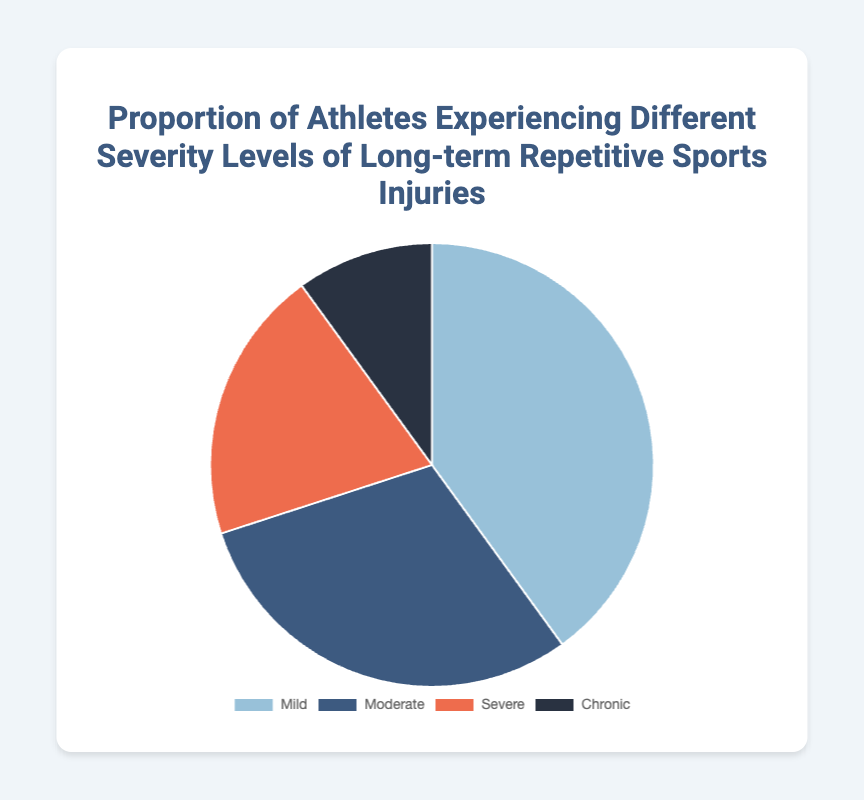What proportion of athletes experienced mild injuries? The slice labeled "Mild" corresponds to 40% of the pie chart's overall composition.
Answer: 40% How does the proportion of athletes with chronic injuries compare to those with severe injuries? The slice labeled "Chronic" represents 10%, while the slice labeled "Severe" represents 20%. Comparing these proportions, athletes with severe injuries account for twice the proportion of those with chronic injuries.
Answer: Severe injuries are twice as common as chronic injuries What is the combined proportion of athletes experiencing severe and chronic injuries? Add the proportions of athletes with severe injuries (20%) and chronic injuries (10%). Thus, the combined proportion is 20% + 10%.
Answer: 30% Which severity level has the largest proportion of athletes? By looking at the sizes of the slices, the "Mild" category accounts for the largest slice, representing 40%.
Answer: Mild What is the discrepancy between the proportion of moderate injuries and chronic injuries? Subtract the proportion of chronic injuries (10%) from the proportion of moderate injuries (30%). Thus, the difference is 30% - 10%.
Answer: 20% What colors represent the different severity levels of injuries in the chart? The chart uses a set of distinct colors for each level: Mild (light blue), Moderate (dark blue), Severe (orange), and Chronic (dark blue-black).
Answer: Mild: light blue, Moderate: dark blue, Severe: orange, Chronic: dark blue-black How much more prevalent are mild injuries than severe injuries? The proportion of mild injuries is 40%, and the proportion of severe injuries is 20%. To find how much more prevalent mild injuries are, subtract 20% from 40%.
Answer: 20% more prevalent By what percentage do moderate injuries exceed chronic injuries? The proportion of moderate injuries is 30%, and chronic injuries are 10%. Subtract 10% from 30% to find the exceeding percentage.
Answer: 20% 